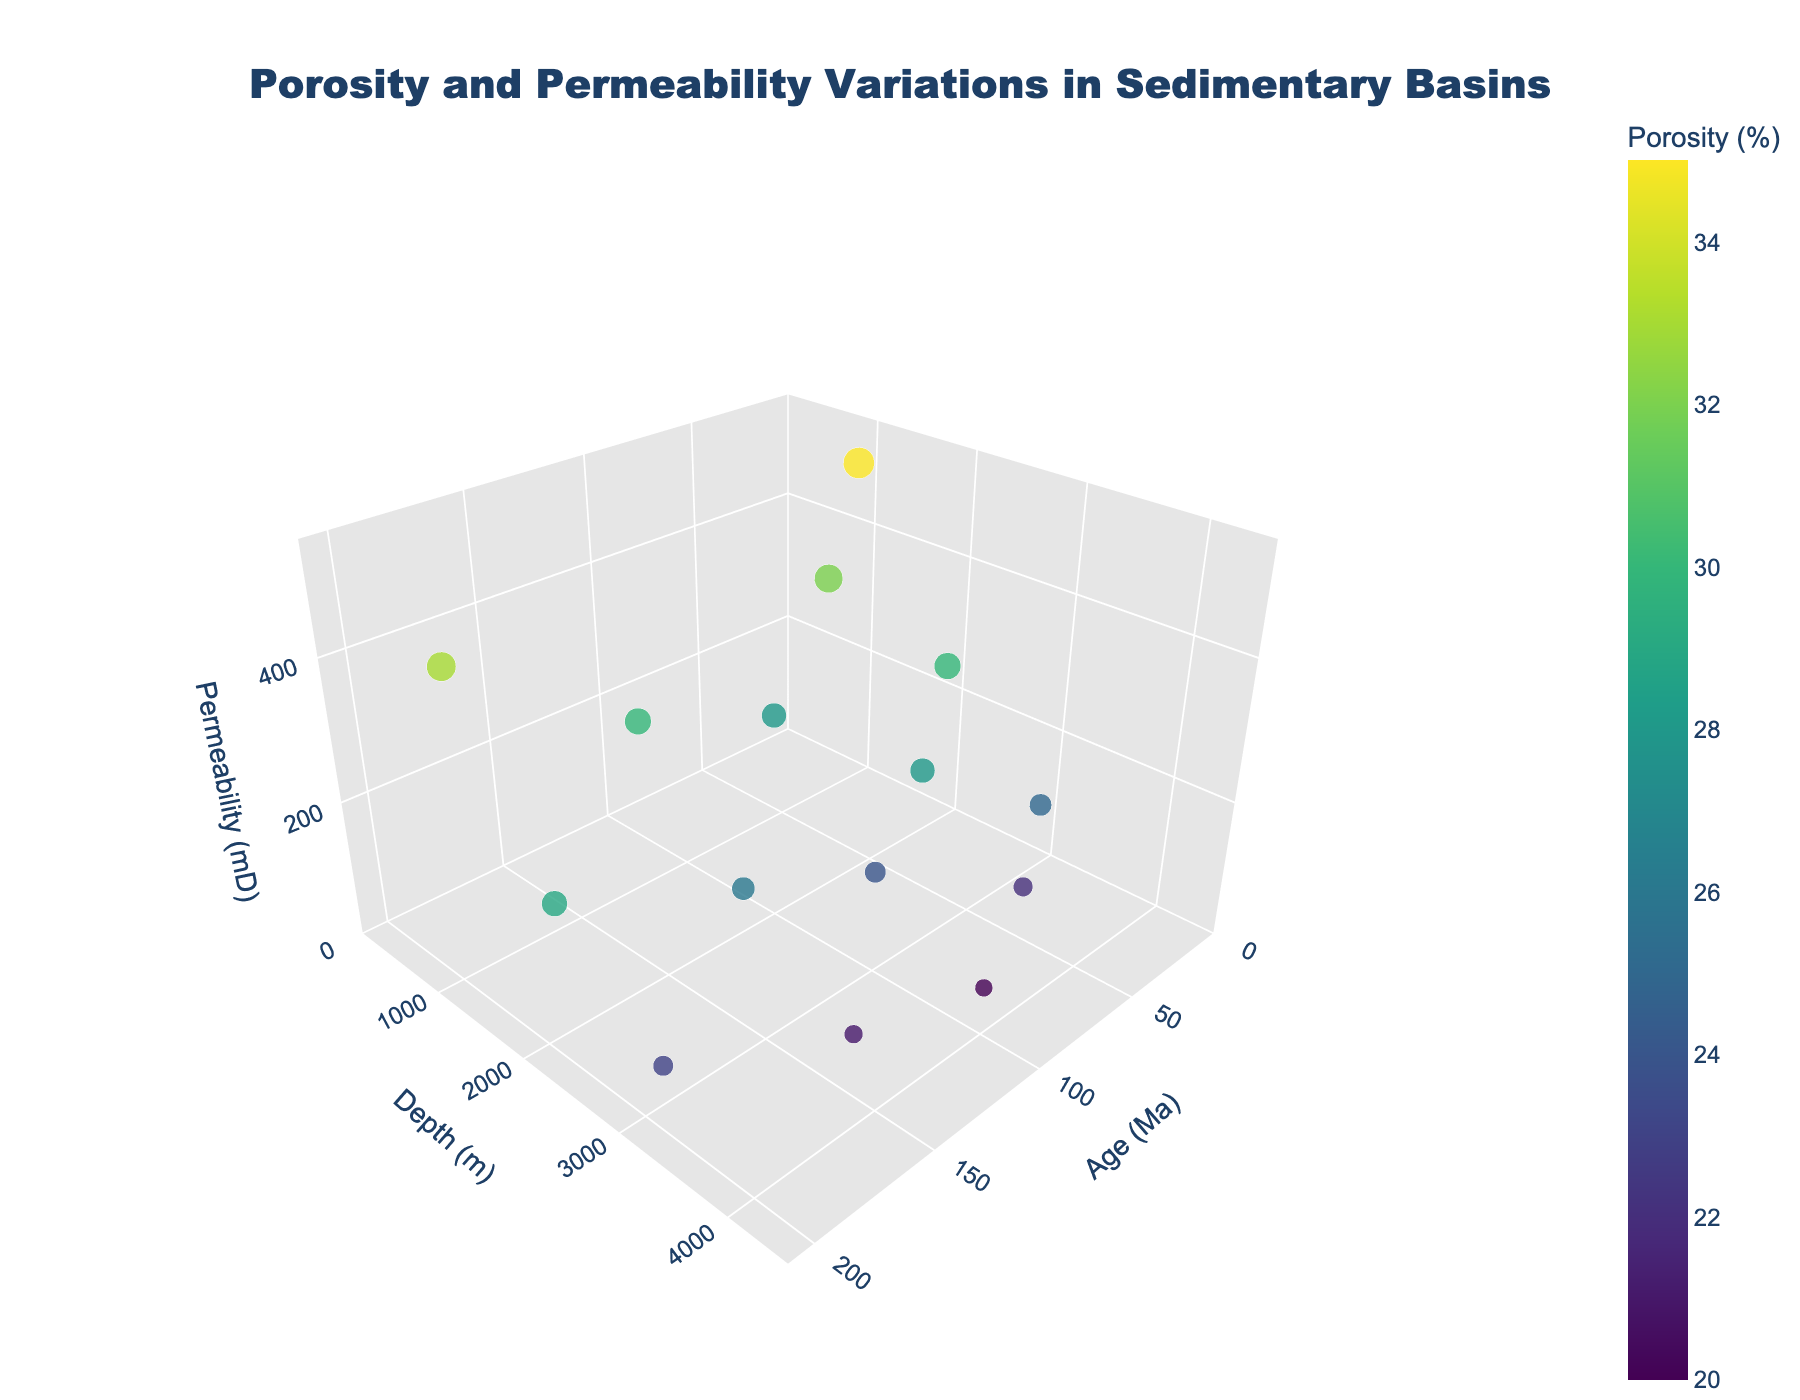what is the title of the figure? The title is positioned at the top center of the figure. It reads: 'Porosity and Permeability Variations in Sedimentary Basins'
Answer: Porosity and Permeability Variations in Sedimentary Basins How many basins are represented in the figure? By examining the 'text' or 'hoverinfo' provided for each point in the 3D plot, you can see the basins. They are Gulf of Mexico, North Sea, Permian Basin, Santos Basin, and Bohai Bay Basin, which makes 5 in total.
Answer: 5 Which basin shows the highest porosity value? By observing the color scale representing porosity and checking the largest marker size, which corresponds to the highest porosity, the Gulf of Mexico at 1000 m depth and 10 Ma shows the highest porosity value of 35%.
Answer: Gulf of Mexico Which depth range exhibits the highest permeability values overall? To determine this, observe the z-axis for permeability values. The highest values (500 mD, 450 mD) are observed in the depth range between 1000 and 1500 meters.
Answer: 1000-1500 meters How does permeability vary with depth in a single basin, for example, the North Sea? The North Sea data points at 1500 m, 2500 m, and 3500 m depths show permeability values of 400 mD, 180 mD, and 80 mD, respectively. This illustrates that permeability decreases with increasing depth in the North Sea basin.
Answer: Decreases with depth Between which two basins is the permeability consistently lower across all measured depths? Bohai Bay Basin and Santos Basin consistently show lower permeability values compared to the Gulf of Mexico and North Sea across their measured depths.
Answer: Bohai Bay Basin and Santos Basin What relationship can be inferred between porosity and permeability from the figure? Generally, larger markers (higher porosity) are found with higher values on the z-axis (permeability). This suggests a positive correlation where higher porosity is often associated with higher permeability.
Answer: Positive correlation Which basin at 200 Ma has the thickest sediments based on the plot's depth axis? At 200 Ma, the Bohai Bay Basin's data points indicate depths of 1200 m, 2200 m, and 3200 m. This suggests that Bohai Bay Basin has deep sedimentary layers, indicating thick sediments relative to other entries.
Answer: Bohai Bay Basin Among the basins, which one maintains the highest permeability with increasing geological age? By plotting age against permeability for each basin, the Gulf of Mexico at 10 Ma shows the highest permeability, maintaining higher values across its data points relative to other basins with older geological ages.
Answer: Gulf of Mexico Which basin is represented by the most number of data points in the plot? Each basin has 3 data points in the plot provided. Since there are no extra entries for any specific basin, all basins are equally represented.
Answer: All basins (tied) 